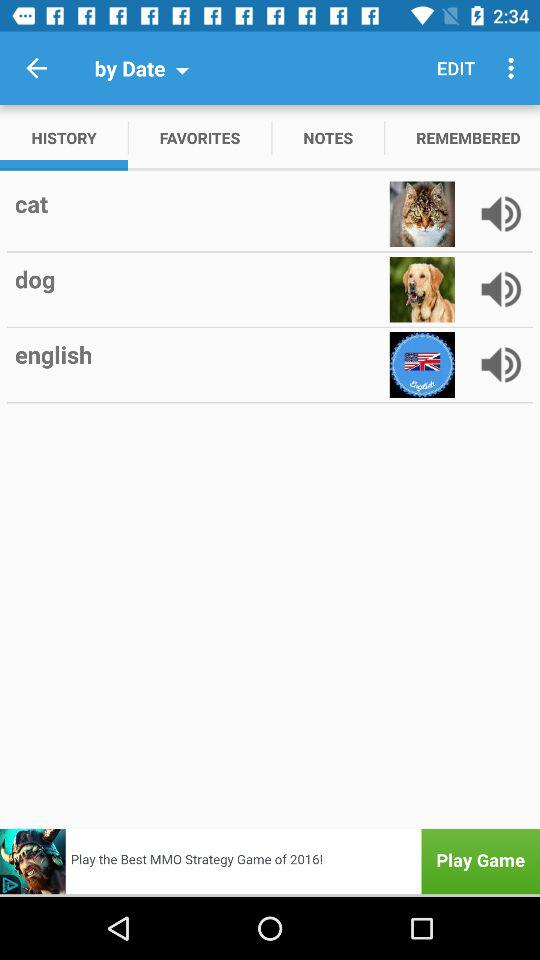When was the last favorite added?
When the provided information is insufficient, respond with <no answer>. <no answer> 